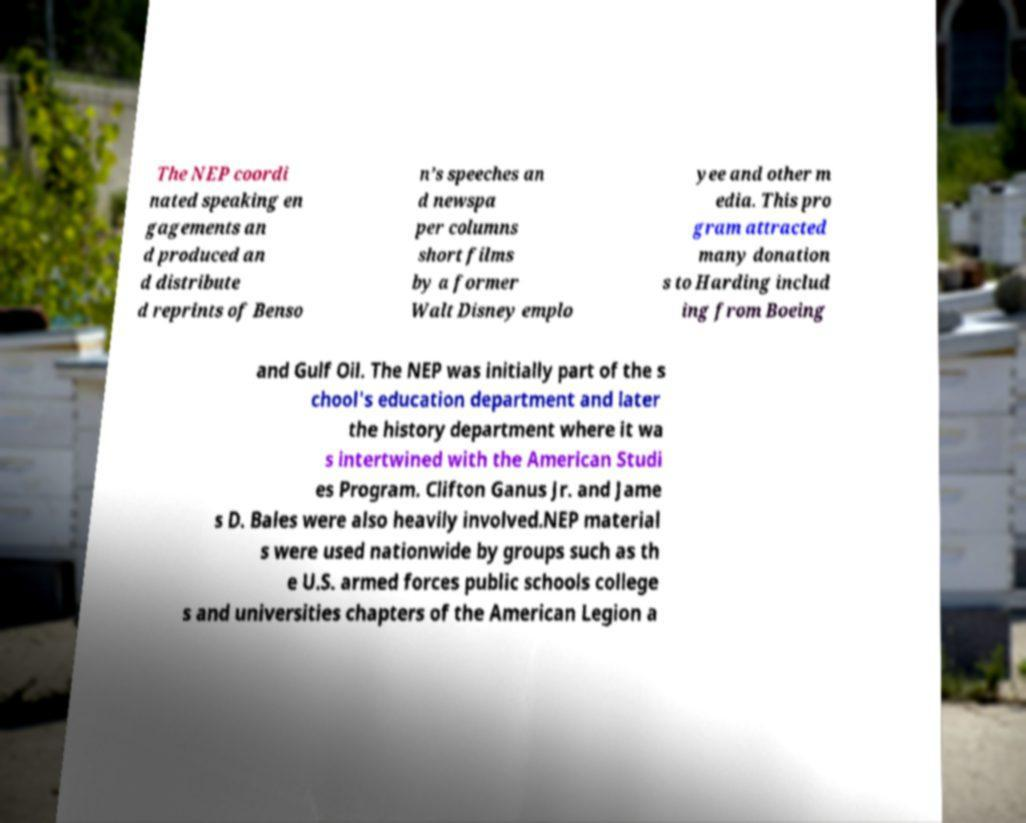There's text embedded in this image that I need extracted. Can you transcribe it verbatim? The NEP coordi nated speaking en gagements an d produced an d distribute d reprints of Benso n’s speeches an d newspa per columns short films by a former Walt Disney emplo yee and other m edia. This pro gram attracted many donation s to Harding includ ing from Boeing and Gulf Oil. The NEP was initially part of the s chool's education department and later the history department where it wa s intertwined with the American Studi es Program. Clifton Ganus Jr. and Jame s D. Bales were also heavily involved.NEP material s were used nationwide by groups such as th e U.S. armed forces public schools college s and universities chapters of the American Legion a 